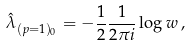Convert formula to latex. <formula><loc_0><loc_0><loc_500><loc_500>\hat { \lambda } _ { ( p = 1 ) _ { 0 } } = - { \frac { 1 } { 2 } } \frac { 1 } { 2 \pi i } \log { w } \, ,</formula> 